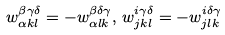Convert formula to latex. <formula><loc_0><loc_0><loc_500><loc_500>w _ { \alpha k l } ^ { \beta \gamma \delta } = - w _ { \alpha l k } ^ { \beta \delta \gamma } , \, w _ { j k l } ^ { i \gamma \delta } = - w _ { j l k } ^ { i \delta \gamma }</formula> 